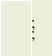Convert code to text. <code><loc_0><loc_0><loc_500><loc_500><_SQL_>;
;
</code> 